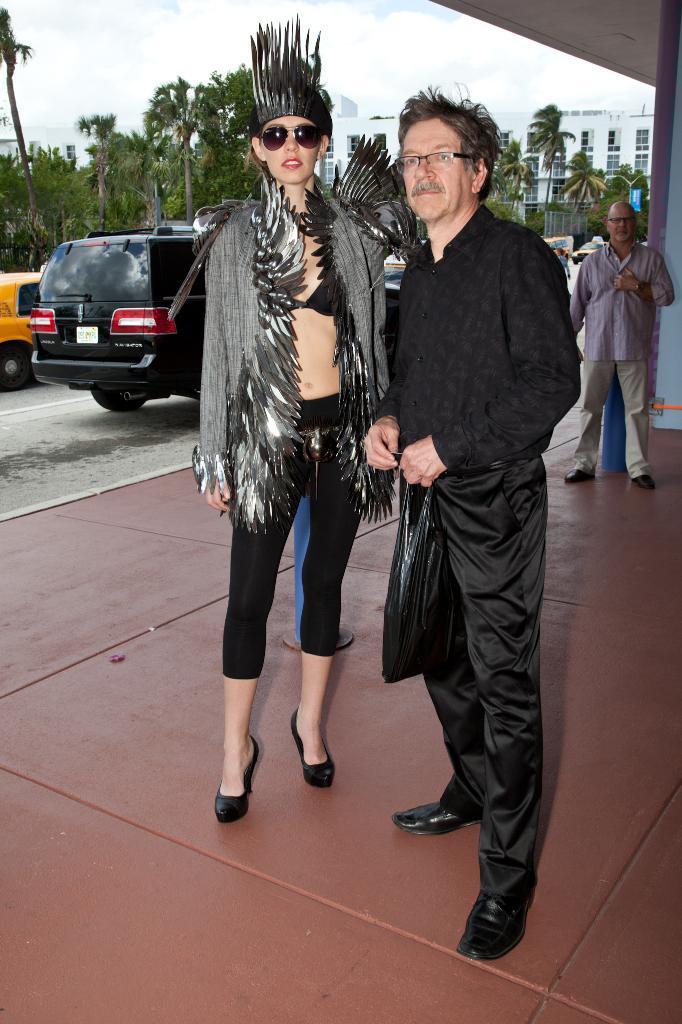Can you describe this image briefly? In this image we can see a man is standing on the floor and holding a cover in his hand and beside him there is a woman. In the background we can see few persons, vehicles on the road, trees, buildings, windows and clouds in the sky. 